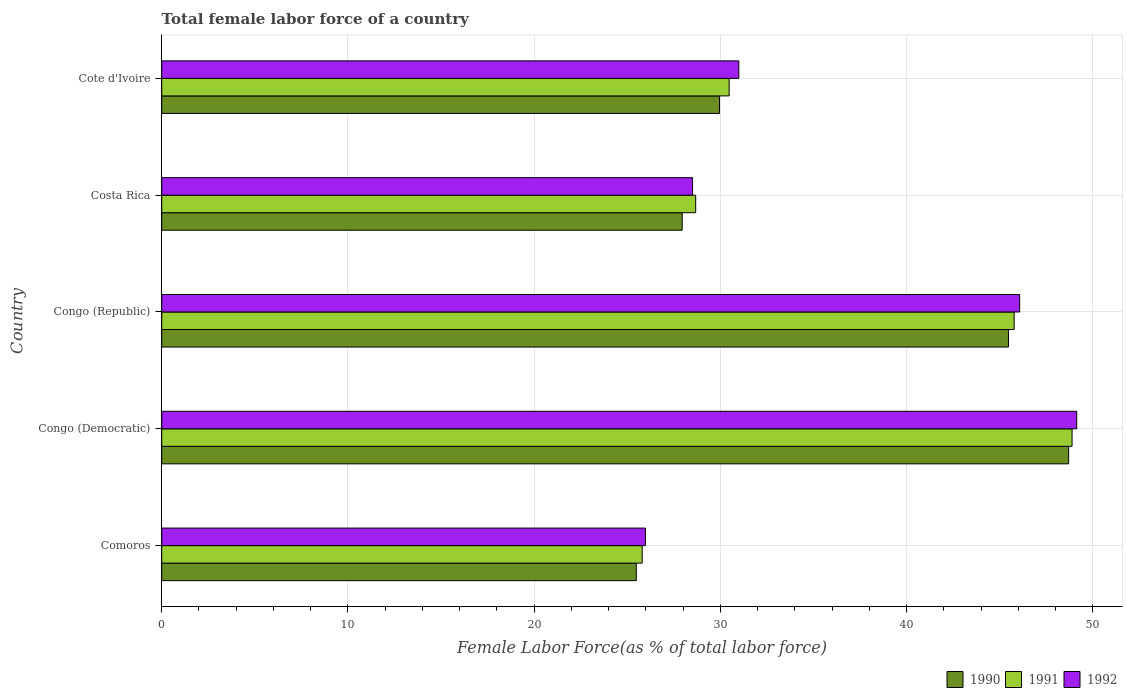How many different coloured bars are there?
Your response must be concise. 3. Are the number of bars on each tick of the Y-axis equal?
Your answer should be very brief. Yes. How many bars are there on the 4th tick from the top?
Your answer should be very brief. 3. What is the label of the 4th group of bars from the top?
Keep it short and to the point. Congo (Democratic). What is the percentage of female labor force in 1990 in Costa Rica?
Give a very brief answer. 27.94. Across all countries, what is the maximum percentage of female labor force in 1991?
Make the answer very short. 48.88. Across all countries, what is the minimum percentage of female labor force in 1992?
Your response must be concise. 25.97. In which country was the percentage of female labor force in 1992 maximum?
Make the answer very short. Congo (Democratic). In which country was the percentage of female labor force in 1990 minimum?
Ensure brevity in your answer.  Comoros. What is the total percentage of female labor force in 1991 in the graph?
Make the answer very short. 179.58. What is the difference between the percentage of female labor force in 1992 in Costa Rica and that in Cote d'Ivoire?
Provide a succinct answer. -2.48. What is the difference between the percentage of female labor force in 1992 in Comoros and the percentage of female labor force in 1990 in Congo (Republic)?
Keep it short and to the point. -19.49. What is the average percentage of female labor force in 1991 per country?
Offer a very short reply. 35.92. What is the difference between the percentage of female labor force in 1992 and percentage of female labor force in 1991 in Comoros?
Make the answer very short. 0.17. What is the ratio of the percentage of female labor force in 1992 in Congo (Democratic) to that in Cote d'Ivoire?
Offer a very short reply. 1.59. Is the percentage of female labor force in 1992 in Congo (Democratic) less than that in Congo (Republic)?
Provide a succinct answer. No. What is the difference between the highest and the second highest percentage of female labor force in 1990?
Provide a short and direct response. 3.23. What is the difference between the highest and the lowest percentage of female labor force in 1990?
Offer a terse response. 23.21. What does the 2nd bar from the bottom in Congo (Republic) represents?
Provide a short and direct response. 1991. Is it the case that in every country, the sum of the percentage of female labor force in 1992 and percentage of female labor force in 1990 is greater than the percentage of female labor force in 1991?
Keep it short and to the point. Yes. How many countries are there in the graph?
Your answer should be compact. 5. What is the difference between two consecutive major ticks on the X-axis?
Offer a very short reply. 10. Are the values on the major ticks of X-axis written in scientific E-notation?
Offer a terse response. No. Does the graph contain grids?
Ensure brevity in your answer.  Yes. Where does the legend appear in the graph?
Your answer should be very brief. Bottom right. What is the title of the graph?
Your answer should be compact. Total female labor force of a country. Does "2007" appear as one of the legend labels in the graph?
Ensure brevity in your answer.  No. What is the label or title of the X-axis?
Offer a very short reply. Female Labor Force(as % of total labor force). What is the label or title of the Y-axis?
Your answer should be very brief. Country. What is the Female Labor Force(as % of total labor force) in 1990 in Comoros?
Give a very brief answer. 25.48. What is the Female Labor Force(as % of total labor force) in 1991 in Comoros?
Your answer should be very brief. 25.8. What is the Female Labor Force(as % of total labor force) of 1992 in Comoros?
Offer a very short reply. 25.97. What is the Female Labor Force(as % of total labor force) of 1990 in Congo (Democratic)?
Ensure brevity in your answer.  48.69. What is the Female Labor Force(as % of total labor force) of 1991 in Congo (Democratic)?
Make the answer very short. 48.88. What is the Female Labor Force(as % of total labor force) of 1992 in Congo (Democratic)?
Keep it short and to the point. 49.13. What is the Female Labor Force(as % of total labor force) in 1990 in Congo (Republic)?
Offer a terse response. 45.46. What is the Female Labor Force(as % of total labor force) of 1991 in Congo (Republic)?
Provide a short and direct response. 45.77. What is the Female Labor Force(as % of total labor force) of 1992 in Congo (Republic)?
Offer a terse response. 46.06. What is the Female Labor Force(as % of total labor force) in 1990 in Costa Rica?
Offer a terse response. 27.94. What is the Female Labor Force(as % of total labor force) of 1991 in Costa Rica?
Provide a short and direct response. 28.67. What is the Female Labor Force(as % of total labor force) of 1992 in Costa Rica?
Your answer should be compact. 28.5. What is the Female Labor Force(as % of total labor force) of 1990 in Cote d'Ivoire?
Provide a short and direct response. 29.95. What is the Female Labor Force(as % of total labor force) in 1991 in Cote d'Ivoire?
Your answer should be compact. 30.47. What is the Female Labor Force(as % of total labor force) in 1992 in Cote d'Ivoire?
Keep it short and to the point. 30.99. Across all countries, what is the maximum Female Labor Force(as % of total labor force) of 1990?
Your answer should be very brief. 48.69. Across all countries, what is the maximum Female Labor Force(as % of total labor force) of 1991?
Keep it short and to the point. 48.88. Across all countries, what is the maximum Female Labor Force(as % of total labor force) in 1992?
Make the answer very short. 49.13. Across all countries, what is the minimum Female Labor Force(as % of total labor force) in 1990?
Provide a short and direct response. 25.48. Across all countries, what is the minimum Female Labor Force(as % of total labor force) in 1991?
Keep it short and to the point. 25.8. Across all countries, what is the minimum Female Labor Force(as % of total labor force) of 1992?
Offer a terse response. 25.97. What is the total Female Labor Force(as % of total labor force) of 1990 in the graph?
Provide a short and direct response. 177.53. What is the total Female Labor Force(as % of total labor force) in 1991 in the graph?
Give a very brief answer. 179.58. What is the total Female Labor Force(as % of total labor force) of 1992 in the graph?
Provide a short and direct response. 180.65. What is the difference between the Female Labor Force(as % of total labor force) of 1990 in Comoros and that in Congo (Democratic)?
Provide a succinct answer. -23.21. What is the difference between the Female Labor Force(as % of total labor force) of 1991 in Comoros and that in Congo (Democratic)?
Your answer should be compact. -23.08. What is the difference between the Female Labor Force(as % of total labor force) of 1992 in Comoros and that in Congo (Democratic)?
Make the answer very short. -23.16. What is the difference between the Female Labor Force(as % of total labor force) of 1990 in Comoros and that in Congo (Republic)?
Your answer should be very brief. -19.98. What is the difference between the Female Labor Force(as % of total labor force) of 1991 in Comoros and that in Congo (Republic)?
Keep it short and to the point. -19.97. What is the difference between the Female Labor Force(as % of total labor force) of 1992 in Comoros and that in Congo (Republic)?
Offer a very short reply. -20.09. What is the difference between the Female Labor Force(as % of total labor force) of 1990 in Comoros and that in Costa Rica?
Provide a short and direct response. -2.46. What is the difference between the Female Labor Force(as % of total labor force) in 1991 in Comoros and that in Costa Rica?
Your response must be concise. -2.87. What is the difference between the Female Labor Force(as % of total labor force) in 1992 in Comoros and that in Costa Rica?
Offer a terse response. -2.53. What is the difference between the Female Labor Force(as % of total labor force) of 1990 in Comoros and that in Cote d'Ivoire?
Offer a very short reply. -4.47. What is the difference between the Female Labor Force(as % of total labor force) of 1991 in Comoros and that in Cote d'Ivoire?
Keep it short and to the point. -4.67. What is the difference between the Female Labor Force(as % of total labor force) of 1992 in Comoros and that in Cote d'Ivoire?
Keep it short and to the point. -5.01. What is the difference between the Female Labor Force(as % of total labor force) of 1990 in Congo (Democratic) and that in Congo (Republic)?
Your answer should be compact. 3.23. What is the difference between the Female Labor Force(as % of total labor force) in 1991 in Congo (Democratic) and that in Congo (Republic)?
Provide a short and direct response. 3.11. What is the difference between the Female Labor Force(as % of total labor force) of 1992 in Congo (Democratic) and that in Congo (Republic)?
Provide a succinct answer. 3.07. What is the difference between the Female Labor Force(as % of total labor force) of 1990 in Congo (Democratic) and that in Costa Rica?
Offer a terse response. 20.75. What is the difference between the Female Labor Force(as % of total labor force) of 1991 in Congo (Democratic) and that in Costa Rica?
Offer a terse response. 20.21. What is the difference between the Female Labor Force(as % of total labor force) of 1992 in Congo (Democratic) and that in Costa Rica?
Ensure brevity in your answer.  20.63. What is the difference between the Female Labor Force(as % of total labor force) in 1990 in Congo (Democratic) and that in Cote d'Ivoire?
Give a very brief answer. 18.75. What is the difference between the Female Labor Force(as % of total labor force) in 1991 in Congo (Democratic) and that in Cote d'Ivoire?
Offer a very short reply. 18.41. What is the difference between the Female Labor Force(as % of total labor force) of 1992 in Congo (Democratic) and that in Cote d'Ivoire?
Ensure brevity in your answer.  18.14. What is the difference between the Female Labor Force(as % of total labor force) of 1990 in Congo (Republic) and that in Costa Rica?
Offer a terse response. 17.52. What is the difference between the Female Labor Force(as % of total labor force) of 1991 in Congo (Republic) and that in Costa Rica?
Keep it short and to the point. 17.1. What is the difference between the Female Labor Force(as % of total labor force) of 1992 in Congo (Republic) and that in Costa Rica?
Make the answer very short. 17.56. What is the difference between the Female Labor Force(as % of total labor force) in 1990 in Congo (Republic) and that in Cote d'Ivoire?
Offer a terse response. 15.52. What is the difference between the Female Labor Force(as % of total labor force) of 1991 in Congo (Republic) and that in Cote d'Ivoire?
Keep it short and to the point. 15.3. What is the difference between the Female Labor Force(as % of total labor force) of 1992 in Congo (Republic) and that in Cote d'Ivoire?
Provide a succinct answer. 15.08. What is the difference between the Female Labor Force(as % of total labor force) in 1990 in Costa Rica and that in Cote d'Ivoire?
Your answer should be compact. -2. What is the difference between the Female Labor Force(as % of total labor force) of 1991 in Costa Rica and that in Cote d'Ivoire?
Ensure brevity in your answer.  -1.8. What is the difference between the Female Labor Force(as % of total labor force) of 1992 in Costa Rica and that in Cote d'Ivoire?
Keep it short and to the point. -2.48. What is the difference between the Female Labor Force(as % of total labor force) of 1990 in Comoros and the Female Labor Force(as % of total labor force) of 1991 in Congo (Democratic)?
Offer a very short reply. -23.4. What is the difference between the Female Labor Force(as % of total labor force) of 1990 in Comoros and the Female Labor Force(as % of total labor force) of 1992 in Congo (Democratic)?
Ensure brevity in your answer.  -23.65. What is the difference between the Female Labor Force(as % of total labor force) of 1991 in Comoros and the Female Labor Force(as % of total labor force) of 1992 in Congo (Democratic)?
Make the answer very short. -23.33. What is the difference between the Female Labor Force(as % of total labor force) of 1990 in Comoros and the Female Labor Force(as % of total labor force) of 1991 in Congo (Republic)?
Your answer should be very brief. -20.29. What is the difference between the Female Labor Force(as % of total labor force) in 1990 in Comoros and the Female Labor Force(as % of total labor force) in 1992 in Congo (Republic)?
Ensure brevity in your answer.  -20.58. What is the difference between the Female Labor Force(as % of total labor force) of 1991 in Comoros and the Female Labor Force(as % of total labor force) of 1992 in Congo (Republic)?
Make the answer very short. -20.27. What is the difference between the Female Labor Force(as % of total labor force) of 1990 in Comoros and the Female Labor Force(as % of total labor force) of 1991 in Costa Rica?
Offer a very short reply. -3.19. What is the difference between the Female Labor Force(as % of total labor force) of 1990 in Comoros and the Female Labor Force(as % of total labor force) of 1992 in Costa Rica?
Offer a terse response. -3.02. What is the difference between the Female Labor Force(as % of total labor force) in 1991 in Comoros and the Female Labor Force(as % of total labor force) in 1992 in Costa Rica?
Your answer should be compact. -2.71. What is the difference between the Female Labor Force(as % of total labor force) in 1990 in Comoros and the Female Labor Force(as % of total labor force) in 1991 in Cote d'Ivoire?
Provide a succinct answer. -4.99. What is the difference between the Female Labor Force(as % of total labor force) of 1990 in Comoros and the Female Labor Force(as % of total labor force) of 1992 in Cote d'Ivoire?
Your answer should be very brief. -5.51. What is the difference between the Female Labor Force(as % of total labor force) in 1991 in Comoros and the Female Labor Force(as % of total labor force) in 1992 in Cote d'Ivoire?
Your answer should be very brief. -5.19. What is the difference between the Female Labor Force(as % of total labor force) of 1990 in Congo (Democratic) and the Female Labor Force(as % of total labor force) of 1991 in Congo (Republic)?
Ensure brevity in your answer.  2.92. What is the difference between the Female Labor Force(as % of total labor force) in 1990 in Congo (Democratic) and the Female Labor Force(as % of total labor force) in 1992 in Congo (Republic)?
Provide a succinct answer. 2.63. What is the difference between the Female Labor Force(as % of total labor force) in 1991 in Congo (Democratic) and the Female Labor Force(as % of total labor force) in 1992 in Congo (Republic)?
Offer a very short reply. 2.81. What is the difference between the Female Labor Force(as % of total labor force) in 1990 in Congo (Democratic) and the Female Labor Force(as % of total labor force) in 1991 in Costa Rica?
Provide a succinct answer. 20.02. What is the difference between the Female Labor Force(as % of total labor force) of 1990 in Congo (Democratic) and the Female Labor Force(as % of total labor force) of 1992 in Costa Rica?
Your answer should be very brief. 20.19. What is the difference between the Female Labor Force(as % of total labor force) in 1991 in Congo (Democratic) and the Female Labor Force(as % of total labor force) in 1992 in Costa Rica?
Your answer should be very brief. 20.37. What is the difference between the Female Labor Force(as % of total labor force) of 1990 in Congo (Democratic) and the Female Labor Force(as % of total labor force) of 1991 in Cote d'Ivoire?
Offer a terse response. 18.23. What is the difference between the Female Labor Force(as % of total labor force) in 1990 in Congo (Democratic) and the Female Labor Force(as % of total labor force) in 1992 in Cote d'Ivoire?
Your response must be concise. 17.71. What is the difference between the Female Labor Force(as % of total labor force) of 1991 in Congo (Democratic) and the Female Labor Force(as % of total labor force) of 1992 in Cote d'Ivoire?
Your response must be concise. 17.89. What is the difference between the Female Labor Force(as % of total labor force) in 1990 in Congo (Republic) and the Female Labor Force(as % of total labor force) in 1991 in Costa Rica?
Offer a terse response. 16.79. What is the difference between the Female Labor Force(as % of total labor force) in 1990 in Congo (Republic) and the Female Labor Force(as % of total labor force) in 1992 in Costa Rica?
Offer a very short reply. 16.96. What is the difference between the Female Labor Force(as % of total labor force) of 1991 in Congo (Republic) and the Female Labor Force(as % of total labor force) of 1992 in Costa Rica?
Offer a very short reply. 17.27. What is the difference between the Female Labor Force(as % of total labor force) of 1990 in Congo (Republic) and the Female Labor Force(as % of total labor force) of 1991 in Cote d'Ivoire?
Provide a succinct answer. 15. What is the difference between the Female Labor Force(as % of total labor force) of 1990 in Congo (Republic) and the Female Labor Force(as % of total labor force) of 1992 in Cote d'Ivoire?
Give a very brief answer. 14.48. What is the difference between the Female Labor Force(as % of total labor force) in 1991 in Congo (Republic) and the Female Labor Force(as % of total labor force) in 1992 in Cote d'Ivoire?
Provide a succinct answer. 14.78. What is the difference between the Female Labor Force(as % of total labor force) of 1990 in Costa Rica and the Female Labor Force(as % of total labor force) of 1991 in Cote d'Ivoire?
Offer a very short reply. -2.52. What is the difference between the Female Labor Force(as % of total labor force) in 1990 in Costa Rica and the Female Labor Force(as % of total labor force) in 1992 in Cote d'Ivoire?
Your answer should be compact. -3.04. What is the difference between the Female Labor Force(as % of total labor force) in 1991 in Costa Rica and the Female Labor Force(as % of total labor force) in 1992 in Cote d'Ivoire?
Your answer should be compact. -2.32. What is the average Female Labor Force(as % of total labor force) of 1990 per country?
Make the answer very short. 35.51. What is the average Female Labor Force(as % of total labor force) in 1991 per country?
Give a very brief answer. 35.92. What is the average Female Labor Force(as % of total labor force) in 1992 per country?
Keep it short and to the point. 36.13. What is the difference between the Female Labor Force(as % of total labor force) in 1990 and Female Labor Force(as % of total labor force) in 1991 in Comoros?
Your answer should be very brief. -0.32. What is the difference between the Female Labor Force(as % of total labor force) in 1990 and Female Labor Force(as % of total labor force) in 1992 in Comoros?
Your answer should be very brief. -0.49. What is the difference between the Female Labor Force(as % of total labor force) of 1991 and Female Labor Force(as % of total labor force) of 1992 in Comoros?
Make the answer very short. -0.17. What is the difference between the Female Labor Force(as % of total labor force) in 1990 and Female Labor Force(as % of total labor force) in 1991 in Congo (Democratic)?
Provide a succinct answer. -0.18. What is the difference between the Female Labor Force(as % of total labor force) in 1990 and Female Labor Force(as % of total labor force) in 1992 in Congo (Democratic)?
Provide a short and direct response. -0.44. What is the difference between the Female Labor Force(as % of total labor force) in 1991 and Female Labor Force(as % of total labor force) in 1992 in Congo (Democratic)?
Provide a succinct answer. -0.25. What is the difference between the Female Labor Force(as % of total labor force) of 1990 and Female Labor Force(as % of total labor force) of 1991 in Congo (Republic)?
Your answer should be compact. -0.31. What is the difference between the Female Labor Force(as % of total labor force) of 1990 and Female Labor Force(as % of total labor force) of 1992 in Congo (Republic)?
Give a very brief answer. -0.6. What is the difference between the Female Labor Force(as % of total labor force) of 1991 and Female Labor Force(as % of total labor force) of 1992 in Congo (Republic)?
Ensure brevity in your answer.  -0.3. What is the difference between the Female Labor Force(as % of total labor force) of 1990 and Female Labor Force(as % of total labor force) of 1991 in Costa Rica?
Provide a succinct answer. -0.72. What is the difference between the Female Labor Force(as % of total labor force) of 1990 and Female Labor Force(as % of total labor force) of 1992 in Costa Rica?
Offer a terse response. -0.56. What is the difference between the Female Labor Force(as % of total labor force) of 1991 and Female Labor Force(as % of total labor force) of 1992 in Costa Rica?
Provide a succinct answer. 0.17. What is the difference between the Female Labor Force(as % of total labor force) in 1990 and Female Labor Force(as % of total labor force) in 1991 in Cote d'Ivoire?
Your answer should be compact. -0.52. What is the difference between the Female Labor Force(as % of total labor force) of 1990 and Female Labor Force(as % of total labor force) of 1992 in Cote d'Ivoire?
Provide a short and direct response. -1.04. What is the difference between the Female Labor Force(as % of total labor force) of 1991 and Female Labor Force(as % of total labor force) of 1992 in Cote d'Ivoire?
Your response must be concise. -0.52. What is the ratio of the Female Labor Force(as % of total labor force) in 1990 in Comoros to that in Congo (Democratic)?
Ensure brevity in your answer.  0.52. What is the ratio of the Female Labor Force(as % of total labor force) of 1991 in Comoros to that in Congo (Democratic)?
Provide a short and direct response. 0.53. What is the ratio of the Female Labor Force(as % of total labor force) of 1992 in Comoros to that in Congo (Democratic)?
Your answer should be very brief. 0.53. What is the ratio of the Female Labor Force(as % of total labor force) in 1990 in Comoros to that in Congo (Republic)?
Provide a short and direct response. 0.56. What is the ratio of the Female Labor Force(as % of total labor force) in 1991 in Comoros to that in Congo (Republic)?
Keep it short and to the point. 0.56. What is the ratio of the Female Labor Force(as % of total labor force) in 1992 in Comoros to that in Congo (Republic)?
Make the answer very short. 0.56. What is the ratio of the Female Labor Force(as % of total labor force) of 1990 in Comoros to that in Costa Rica?
Provide a succinct answer. 0.91. What is the ratio of the Female Labor Force(as % of total labor force) of 1991 in Comoros to that in Costa Rica?
Your answer should be very brief. 0.9. What is the ratio of the Female Labor Force(as % of total labor force) in 1992 in Comoros to that in Costa Rica?
Offer a very short reply. 0.91. What is the ratio of the Female Labor Force(as % of total labor force) of 1990 in Comoros to that in Cote d'Ivoire?
Ensure brevity in your answer.  0.85. What is the ratio of the Female Labor Force(as % of total labor force) in 1991 in Comoros to that in Cote d'Ivoire?
Give a very brief answer. 0.85. What is the ratio of the Female Labor Force(as % of total labor force) of 1992 in Comoros to that in Cote d'Ivoire?
Provide a short and direct response. 0.84. What is the ratio of the Female Labor Force(as % of total labor force) in 1990 in Congo (Democratic) to that in Congo (Republic)?
Ensure brevity in your answer.  1.07. What is the ratio of the Female Labor Force(as % of total labor force) in 1991 in Congo (Democratic) to that in Congo (Republic)?
Offer a very short reply. 1.07. What is the ratio of the Female Labor Force(as % of total labor force) of 1992 in Congo (Democratic) to that in Congo (Republic)?
Your answer should be compact. 1.07. What is the ratio of the Female Labor Force(as % of total labor force) in 1990 in Congo (Democratic) to that in Costa Rica?
Your answer should be very brief. 1.74. What is the ratio of the Female Labor Force(as % of total labor force) in 1991 in Congo (Democratic) to that in Costa Rica?
Offer a terse response. 1.7. What is the ratio of the Female Labor Force(as % of total labor force) in 1992 in Congo (Democratic) to that in Costa Rica?
Your answer should be compact. 1.72. What is the ratio of the Female Labor Force(as % of total labor force) of 1990 in Congo (Democratic) to that in Cote d'Ivoire?
Keep it short and to the point. 1.63. What is the ratio of the Female Labor Force(as % of total labor force) of 1991 in Congo (Democratic) to that in Cote d'Ivoire?
Ensure brevity in your answer.  1.6. What is the ratio of the Female Labor Force(as % of total labor force) in 1992 in Congo (Democratic) to that in Cote d'Ivoire?
Provide a succinct answer. 1.59. What is the ratio of the Female Labor Force(as % of total labor force) of 1990 in Congo (Republic) to that in Costa Rica?
Your response must be concise. 1.63. What is the ratio of the Female Labor Force(as % of total labor force) in 1991 in Congo (Republic) to that in Costa Rica?
Give a very brief answer. 1.6. What is the ratio of the Female Labor Force(as % of total labor force) in 1992 in Congo (Republic) to that in Costa Rica?
Your response must be concise. 1.62. What is the ratio of the Female Labor Force(as % of total labor force) of 1990 in Congo (Republic) to that in Cote d'Ivoire?
Your answer should be compact. 1.52. What is the ratio of the Female Labor Force(as % of total labor force) of 1991 in Congo (Republic) to that in Cote d'Ivoire?
Ensure brevity in your answer.  1.5. What is the ratio of the Female Labor Force(as % of total labor force) of 1992 in Congo (Republic) to that in Cote d'Ivoire?
Give a very brief answer. 1.49. What is the ratio of the Female Labor Force(as % of total labor force) of 1990 in Costa Rica to that in Cote d'Ivoire?
Provide a short and direct response. 0.93. What is the ratio of the Female Labor Force(as % of total labor force) in 1991 in Costa Rica to that in Cote d'Ivoire?
Your answer should be very brief. 0.94. What is the ratio of the Female Labor Force(as % of total labor force) of 1992 in Costa Rica to that in Cote d'Ivoire?
Give a very brief answer. 0.92. What is the difference between the highest and the second highest Female Labor Force(as % of total labor force) in 1990?
Give a very brief answer. 3.23. What is the difference between the highest and the second highest Female Labor Force(as % of total labor force) of 1991?
Offer a terse response. 3.11. What is the difference between the highest and the second highest Female Labor Force(as % of total labor force) of 1992?
Offer a very short reply. 3.07. What is the difference between the highest and the lowest Female Labor Force(as % of total labor force) of 1990?
Offer a very short reply. 23.21. What is the difference between the highest and the lowest Female Labor Force(as % of total labor force) in 1991?
Make the answer very short. 23.08. What is the difference between the highest and the lowest Female Labor Force(as % of total labor force) of 1992?
Give a very brief answer. 23.16. 